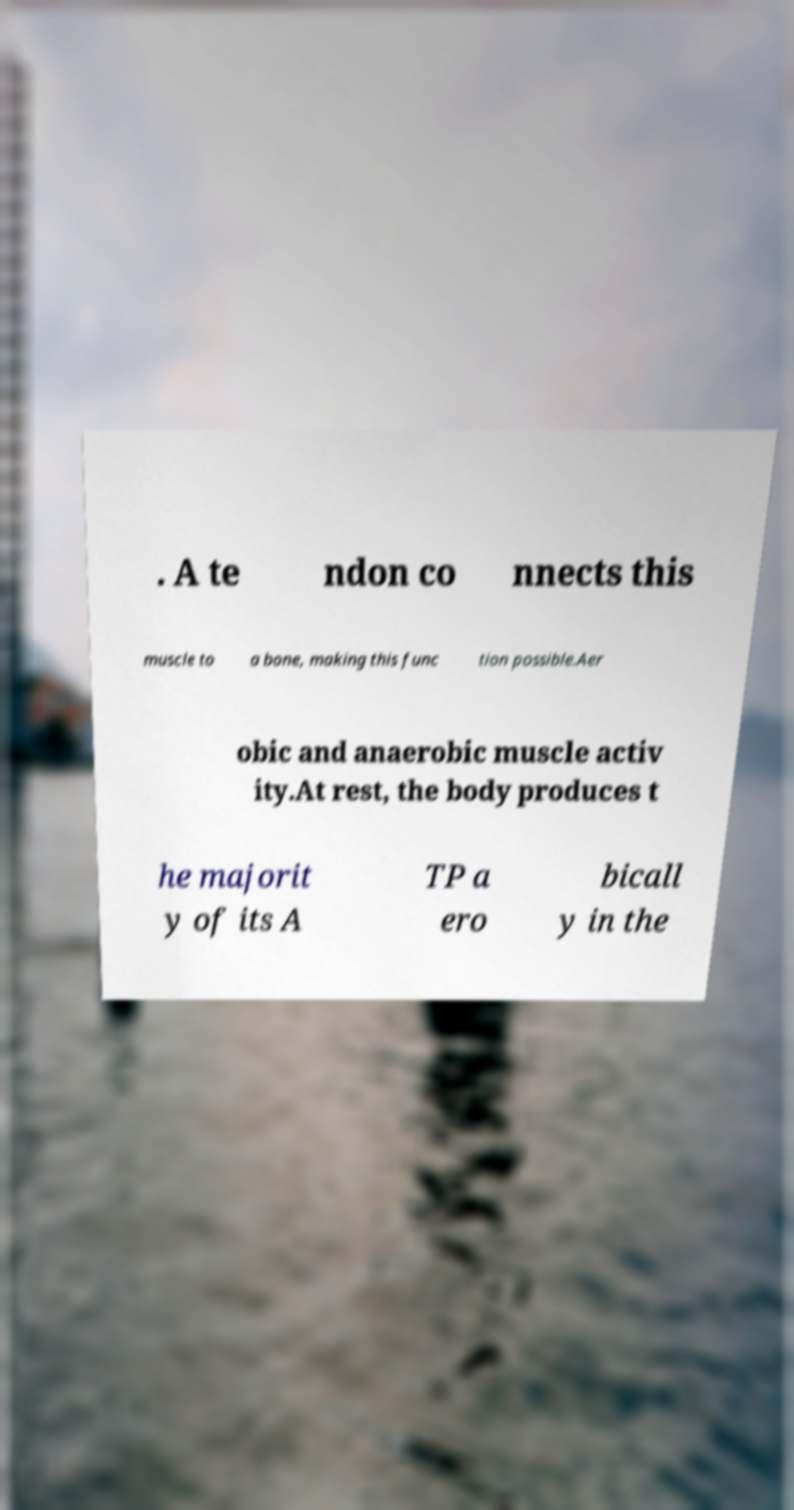Can you read and provide the text displayed in the image?This photo seems to have some interesting text. Can you extract and type it out for me? . A te ndon co nnects this muscle to a bone, making this func tion possible.Aer obic and anaerobic muscle activ ity.At rest, the body produces t he majorit y of its A TP a ero bicall y in the 